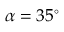<formula> <loc_0><loc_0><loc_500><loc_500>\alpha = 3 5 ^ { \circ }</formula> 